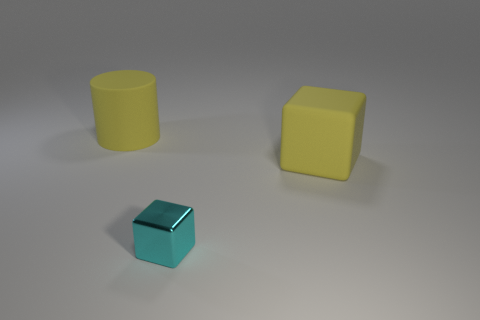Are there any other things that have the same material as the cyan block?
Your response must be concise. No. Is there a yellow block of the same size as the yellow matte cylinder?
Give a very brief answer. Yes. Does the yellow thing that is in front of the cylinder have the same size as the thing that is in front of the yellow block?
Provide a succinct answer. No. The big thing on the left side of the block in front of the big yellow cube is what shape?
Your answer should be compact. Cylinder. What number of large cylinders are right of the small cyan block?
Provide a short and direct response. 0. What is the color of the big block that is made of the same material as the yellow cylinder?
Keep it short and to the point. Yellow. Does the cyan cube have the same size as the yellow thing that is left of the metal cube?
Offer a very short reply. No. How big is the rubber object that is to the right of the yellow rubber object behind the matte thing that is to the right of the large yellow cylinder?
Ensure brevity in your answer.  Large. What number of metal things are cyan objects or large cylinders?
Your response must be concise. 1. There is a big cylinder that is left of the metal block; what color is it?
Make the answer very short. Yellow. 